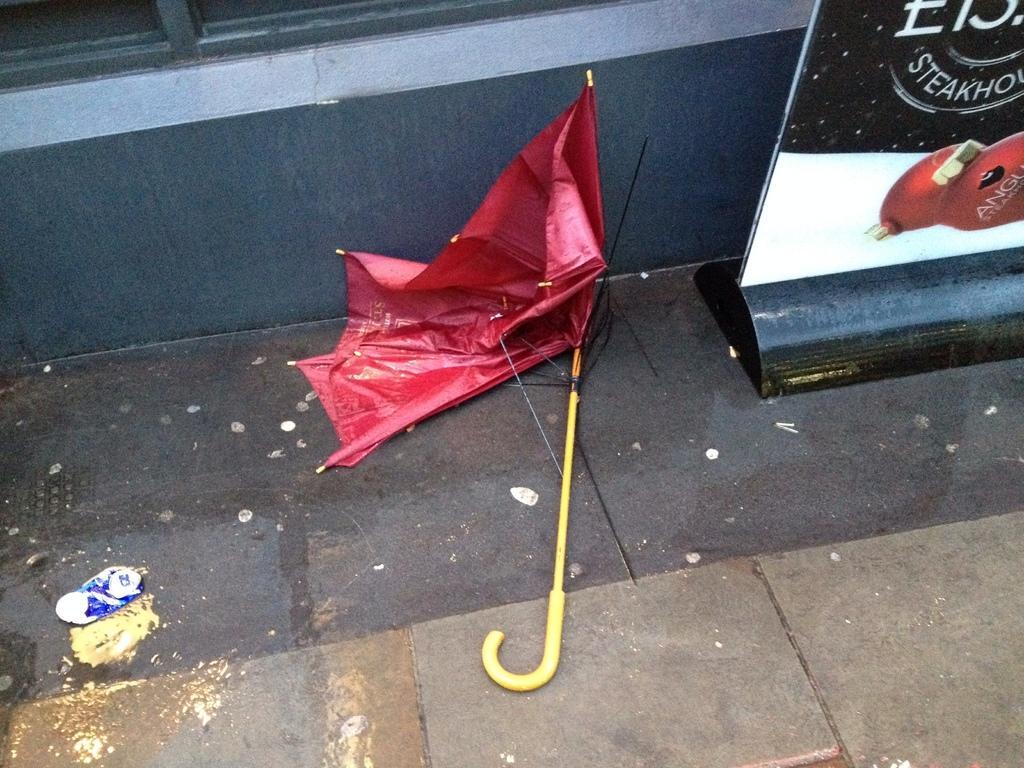In one or two sentences, can you explain what this image depicts? In this image we can see an umbrella and a board with some text and image on the ground, in the background we can see the wall. 